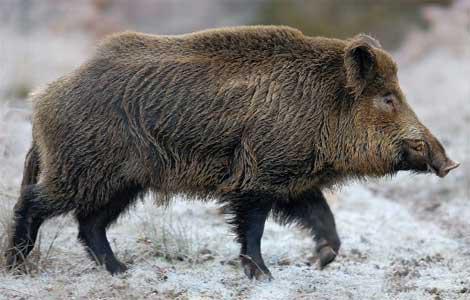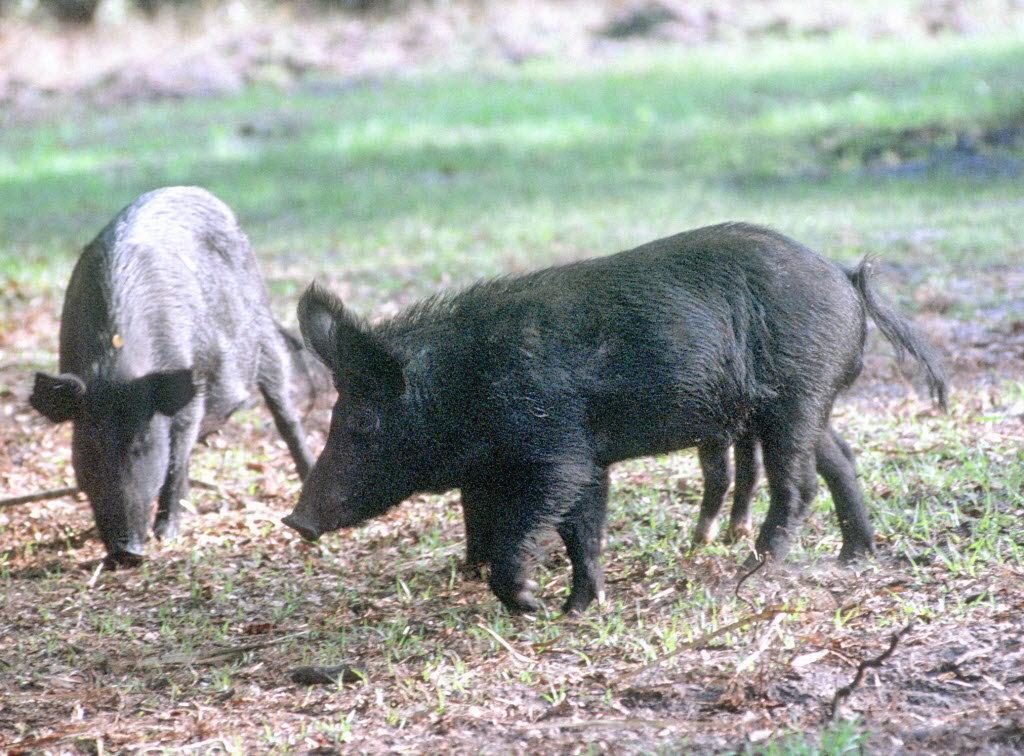The first image is the image on the left, the second image is the image on the right. For the images displayed, is the sentence "An animals is walking with its babies." factually correct? Answer yes or no. No. 